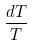Convert formula to latex. <formula><loc_0><loc_0><loc_500><loc_500>\frac { d T } { T }</formula> 